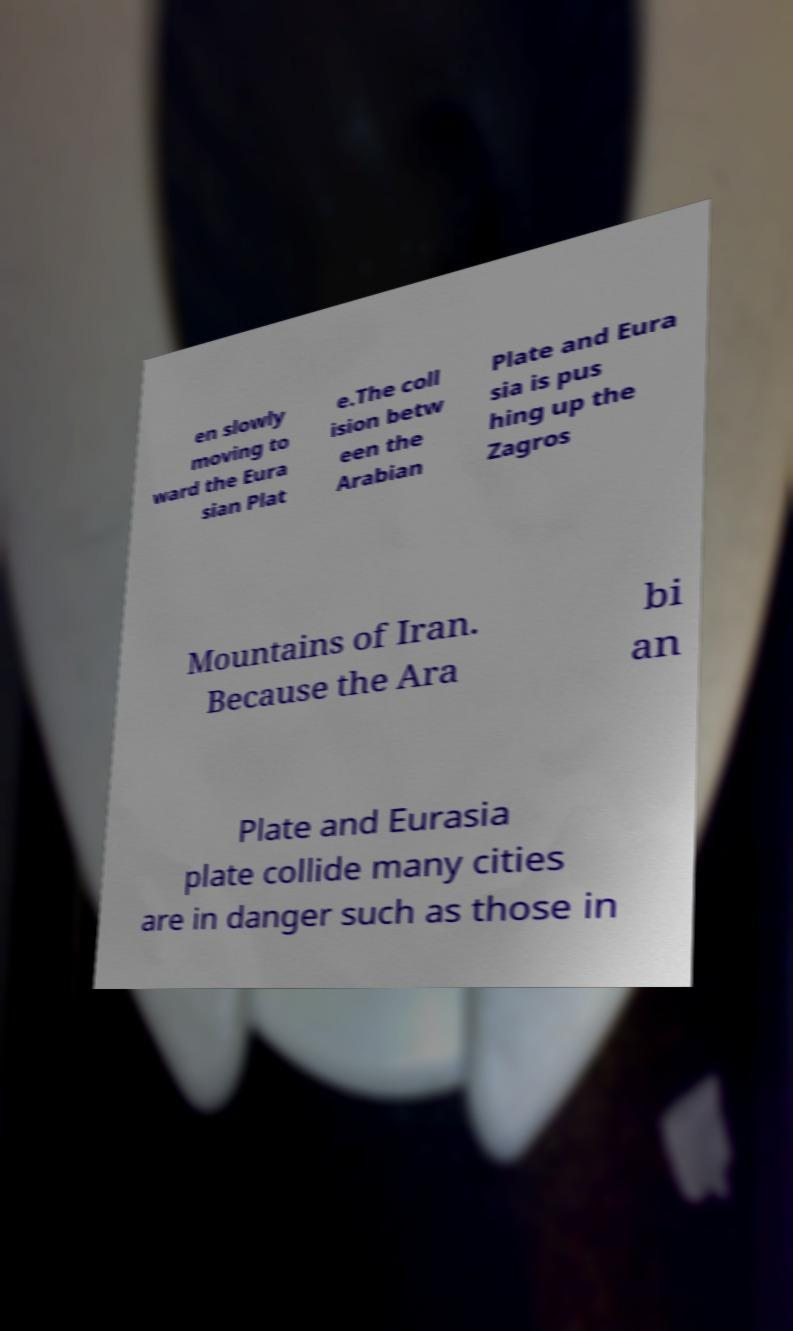Can you read and provide the text displayed in the image?This photo seems to have some interesting text. Can you extract and type it out for me? en slowly moving to ward the Eura sian Plat e.The coll ision betw een the Arabian Plate and Eura sia is pus hing up the Zagros Mountains of Iran. Because the Ara bi an Plate and Eurasia plate collide many cities are in danger such as those in 